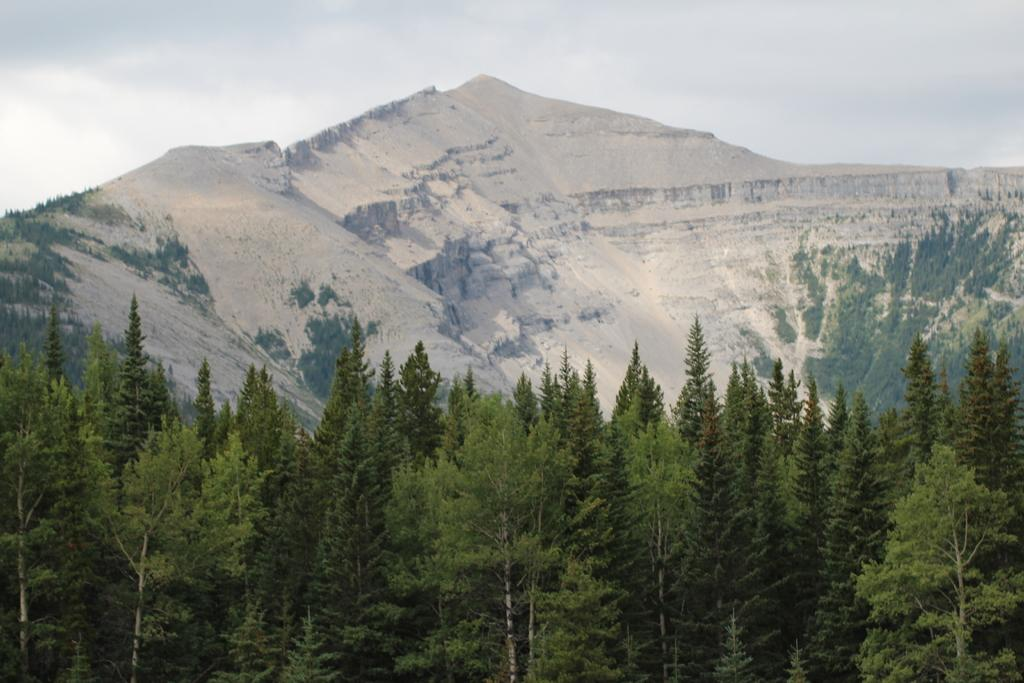What type of vegetation can be seen in the picture? There is a thicket in the picture. What natural feature is visible behind the thicket? There is a mountain behind the thicket. How much is the ticket for the mother to visit the mountain in the image? There is no mention of a ticket or a mother in the image, so it is not possible to answer that question. 